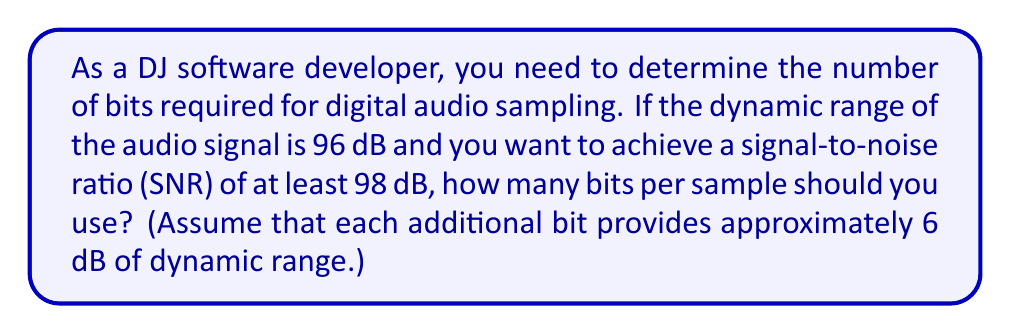Teach me how to tackle this problem. Let's approach this step-by-step:

1) First, we need to determine the total number of dB required. This is the sum of the dynamic range and the desired SNR:

   $96 \text{ dB} + 98 \text{ dB} = 194 \text{ dB}$

2) Now, we know that each bit provides approximately 6 dB of dynamic range. We can set up the following equation:

   $6x = 194$

   Where $x$ is the number of bits we need.

3) To solve for $x$, we divide both sides by 6:

   $x = \frac{194}{6} \approx 32.33$

4) However, we need to use a whole number of bits. Since we want to achieve "at least" 98 dB SNR, we need to round up.

5) To find the ceiling of this value, we can use the ceiling function or logarithms:

   $\text{bits} = \left\lceil \frac{194}{6} \right\rceil = \left\lceil 32.33 \right\rceil = 33$

   Or using logarithms:

   $\text{bits} = \left\lceil \log_2(2^{\frac{194}{6}}) \right\rceil = \left\lceil 32.33 \right\rceil = 33$

Therefore, you should use 33 bits per sample to achieve the desired dynamic range and SNR.
Answer: 33 bits 